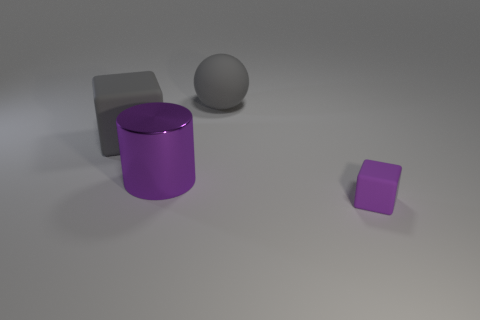Add 4 tiny brown metal cylinders. How many objects exist? 8 Subtract all spheres. How many objects are left? 3 Subtract all small rubber things. Subtract all spheres. How many objects are left? 2 Add 1 gray matte balls. How many gray matte balls are left? 2 Add 1 large purple cylinders. How many large purple cylinders exist? 2 Subtract 0 purple balls. How many objects are left? 4 